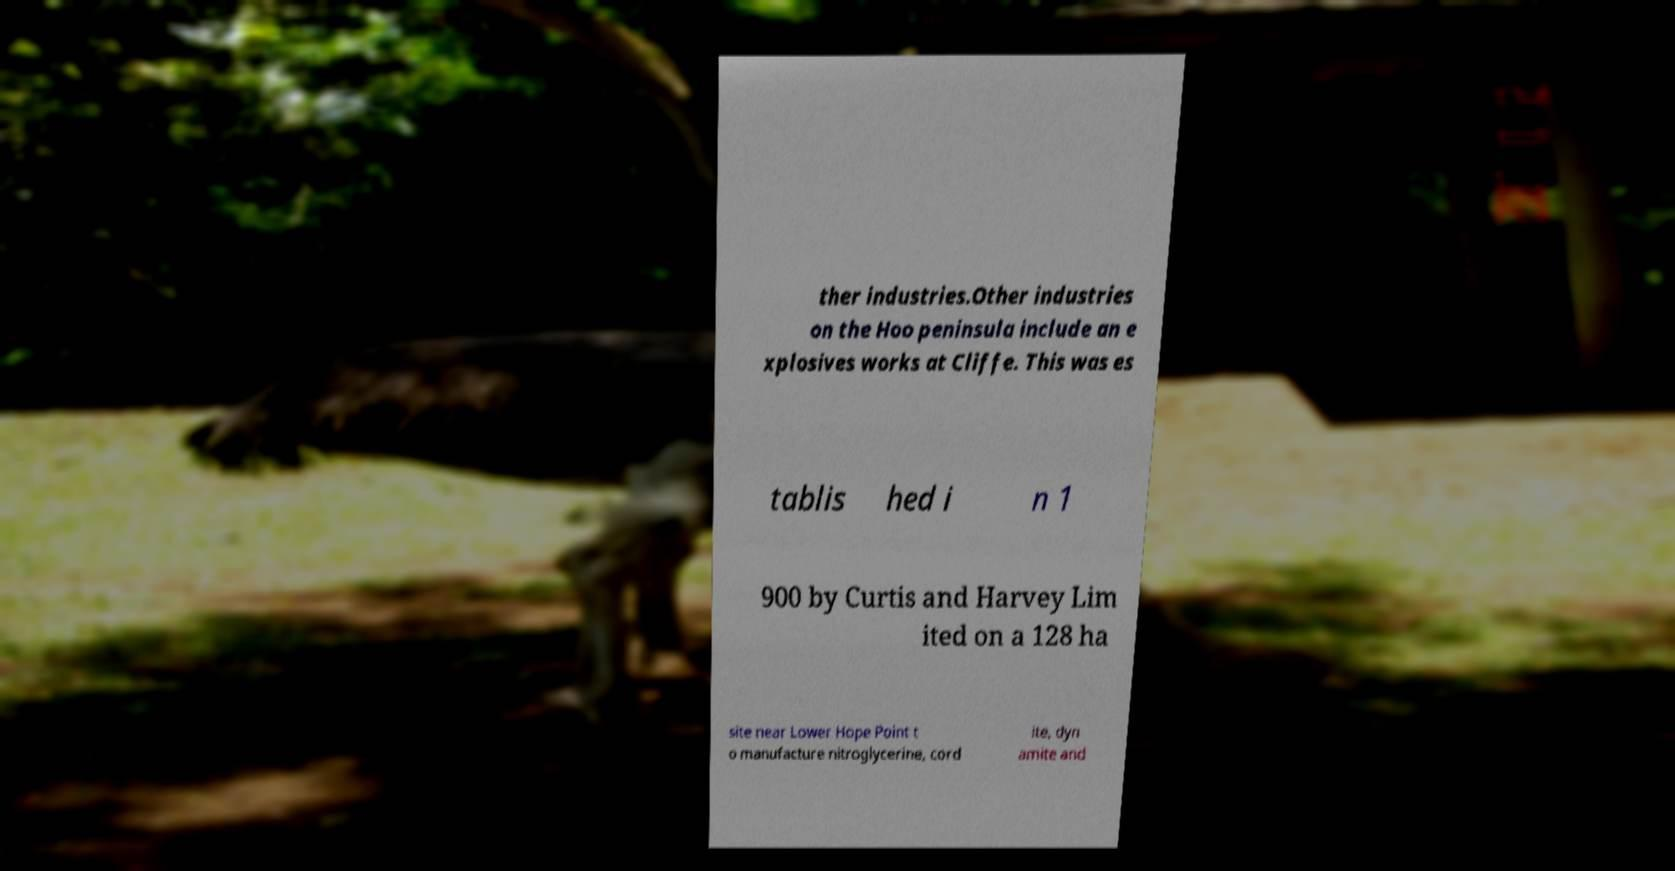For documentation purposes, I need the text within this image transcribed. Could you provide that? ther industries.Other industries on the Hoo peninsula include an e xplosives works at Cliffe. This was es tablis hed i n 1 900 by Curtis and Harvey Lim ited on a 128 ha site near Lower Hope Point t o manufacture nitroglycerine, cord ite, dyn amite and 